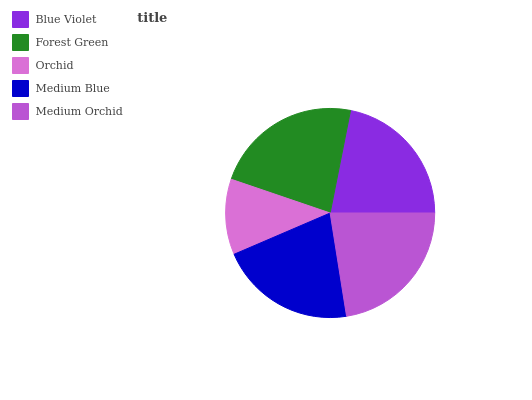Is Orchid the minimum?
Answer yes or no. Yes. Is Forest Green the maximum?
Answer yes or no. Yes. Is Forest Green the minimum?
Answer yes or no. No. Is Orchid the maximum?
Answer yes or no. No. Is Forest Green greater than Orchid?
Answer yes or no. Yes. Is Orchid less than Forest Green?
Answer yes or no. Yes. Is Orchid greater than Forest Green?
Answer yes or no. No. Is Forest Green less than Orchid?
Answer yes or no. No. Is Blue Violet the high median?
Answer yes or no. Yes. Is Blue Violet the low median?
Answer yes or no. Yes. Is Orchid the high median?
Answer yes or no. No. Is Forest Green the low median?
Answer yes or no. No. 